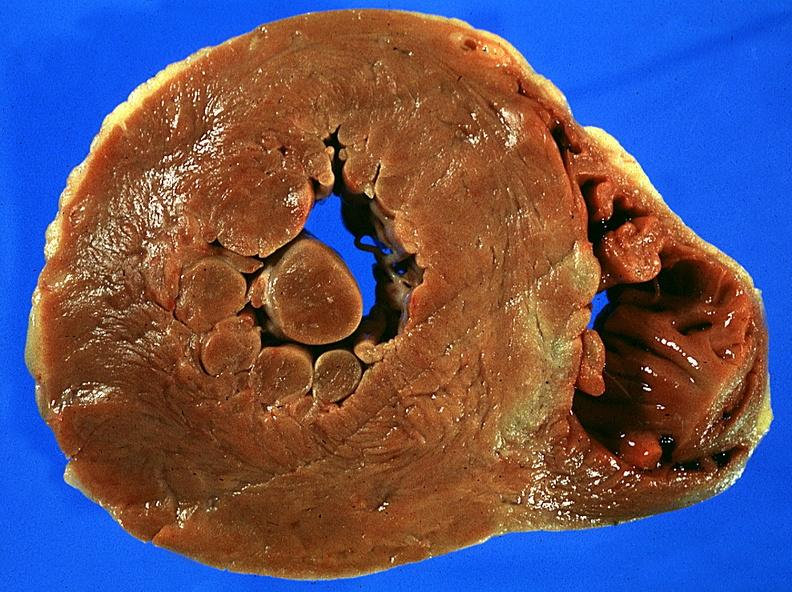does this image show left ventricular hypertrophy?
Answer the question using a single word or phrase. Yes 